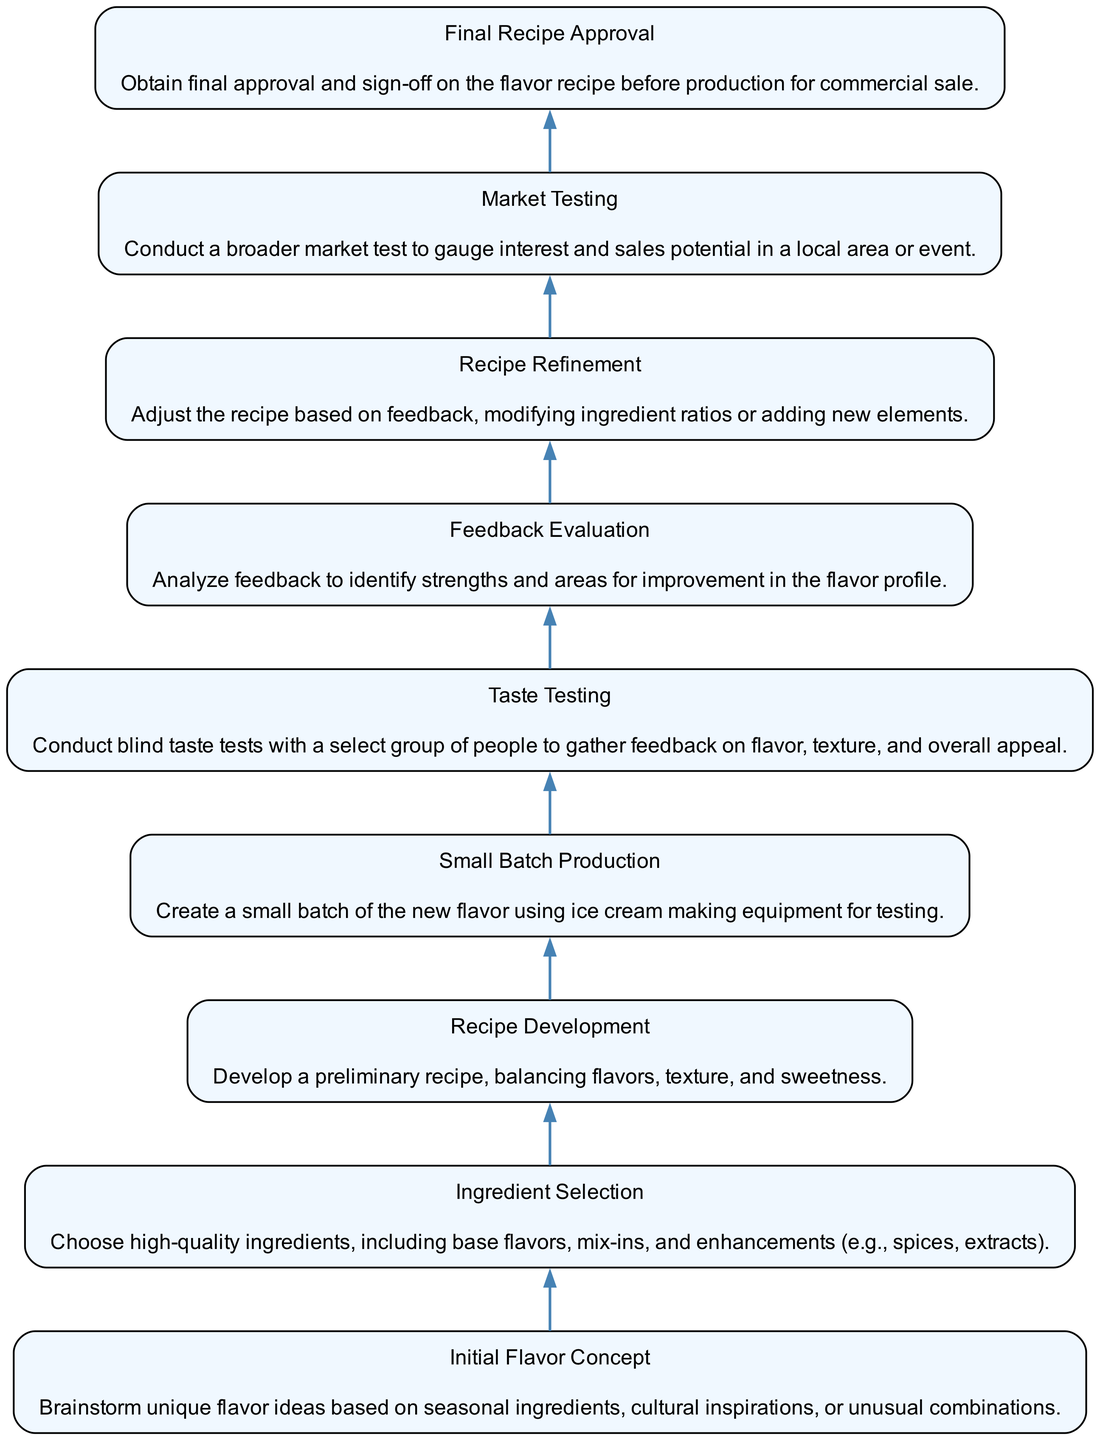What is the first step in the flavor development process? The first step is labeled "Initial Flavor Concept", which highlights it as the starting point for brainstorming unique flavor ideas.
Answer: Initial Flavor Concept How many nodes are present in the diagram? Counting all the different nodes listed in the diagram gives a total of nine distinct steps in the flavor development process.
Answer: 9 What comes immediately after "Small Batch Production"? The element immediately following "Small Batch Production" is "Taste Testing", indicating that testing occurs after making a small batch of the new flavor.
Answer: Taste Testing What is the last step in the flavor development process? The last step is "Final Recipe Approval", which signifies the concluding stage before commercial production begins.
Answer: Final Recipe Approval Which step involves gathering feedback from taste tests? The step titled "Feedback Evaluation" is where the feedback gathered from taste tests is analyzed to inform any adjustments needed.
Answer: Feedback Evaluation How does "Recipe Refinement" relate to "Feedback Evaluation"? "Recipe Refinement" follows "Feedback Evaluation", meaning it is based on the insights gained from evaluating feedback to improve the recipe.
Answer: Recipe Refinement If you're aiming for market interest, which step should you focus on? The step titled "Market Testing" is specifically designed to test how well a flavor might perform in the actual market context.
Answer: Market Testing What type of ingredients are chosen during the ingredient selection phase? The "Ingredient Selection" phase focuses on high-quality ingredients, including base flavors and mix-ins, to ensure a premium ice cream flavor.
Answer: High-quality ingredients What is the purpose of "Taste Testing" in the flavor development process? "Taste Testing" serves to conduct blind taste tests to gather subjective feedback on the flavor, texture, and overall appeal of the ice cream.
Answer: Gather feedback on flavor, texture, and overall appeal 